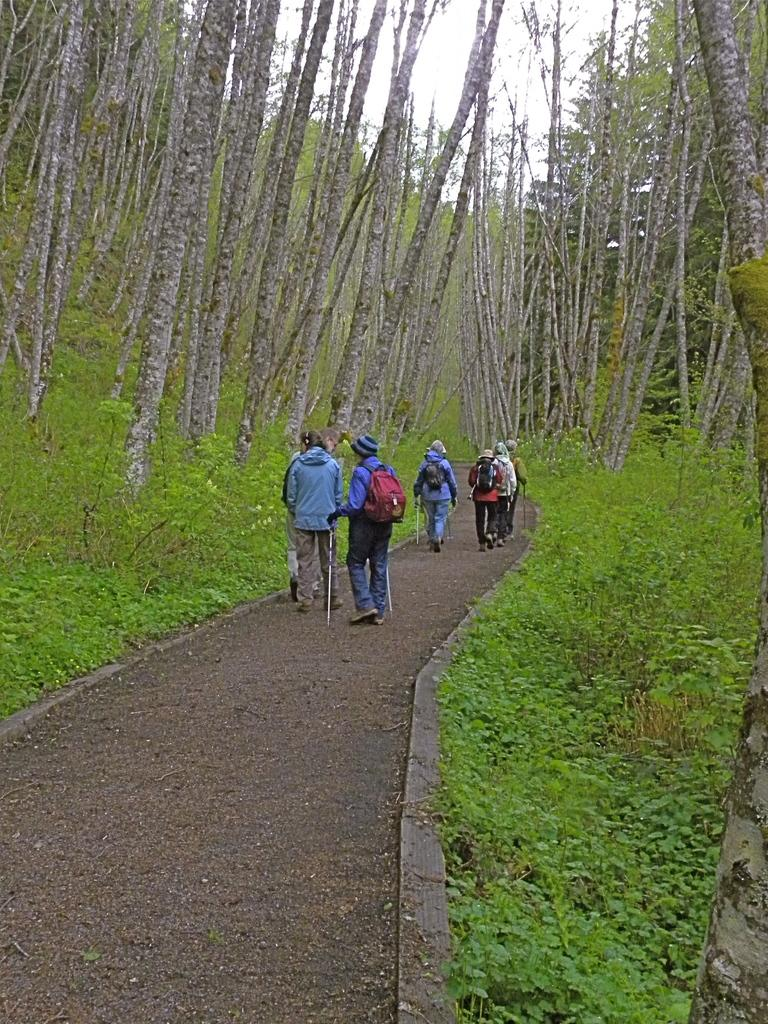How many people are in the image? There are people in the image, but the exact number is not specified. What are the people carrying on their backs? The people are wearing backpacks. What are the people holding in their hands? The people are holding two sticks. What are the people doing in the image? The people are walking along a pathway. What type of vegetation can be seen in the image? There are small bushes and plants, as well as tall trees beside the pathway. What type of lettuce is growing in the zoo in the image? There is no lettuce or zoo present in the image; it features people walking along a pathway with backpacks and sticks, surrounded by small bushes, plants, and tall trees. 